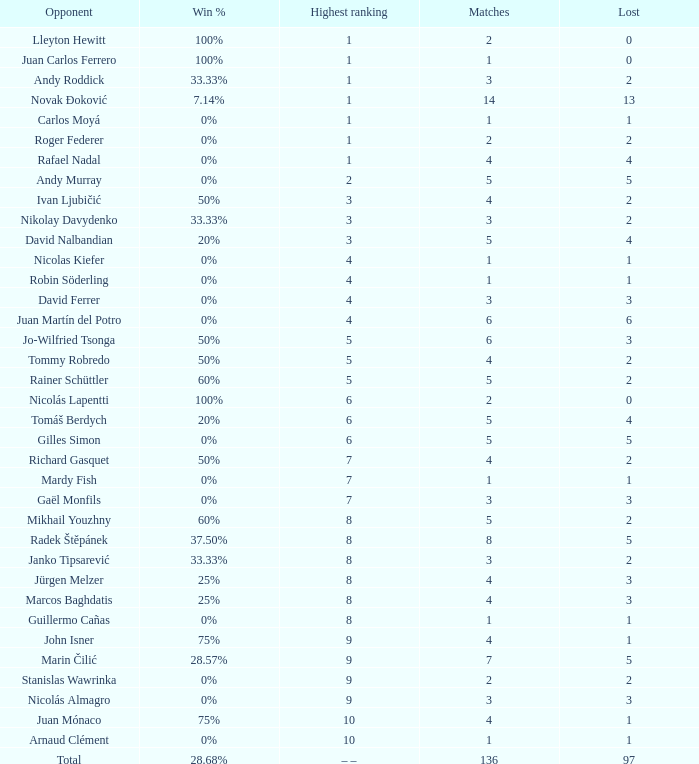What is the total number of Lost for the Highest Ranking of – –? 1.0. 